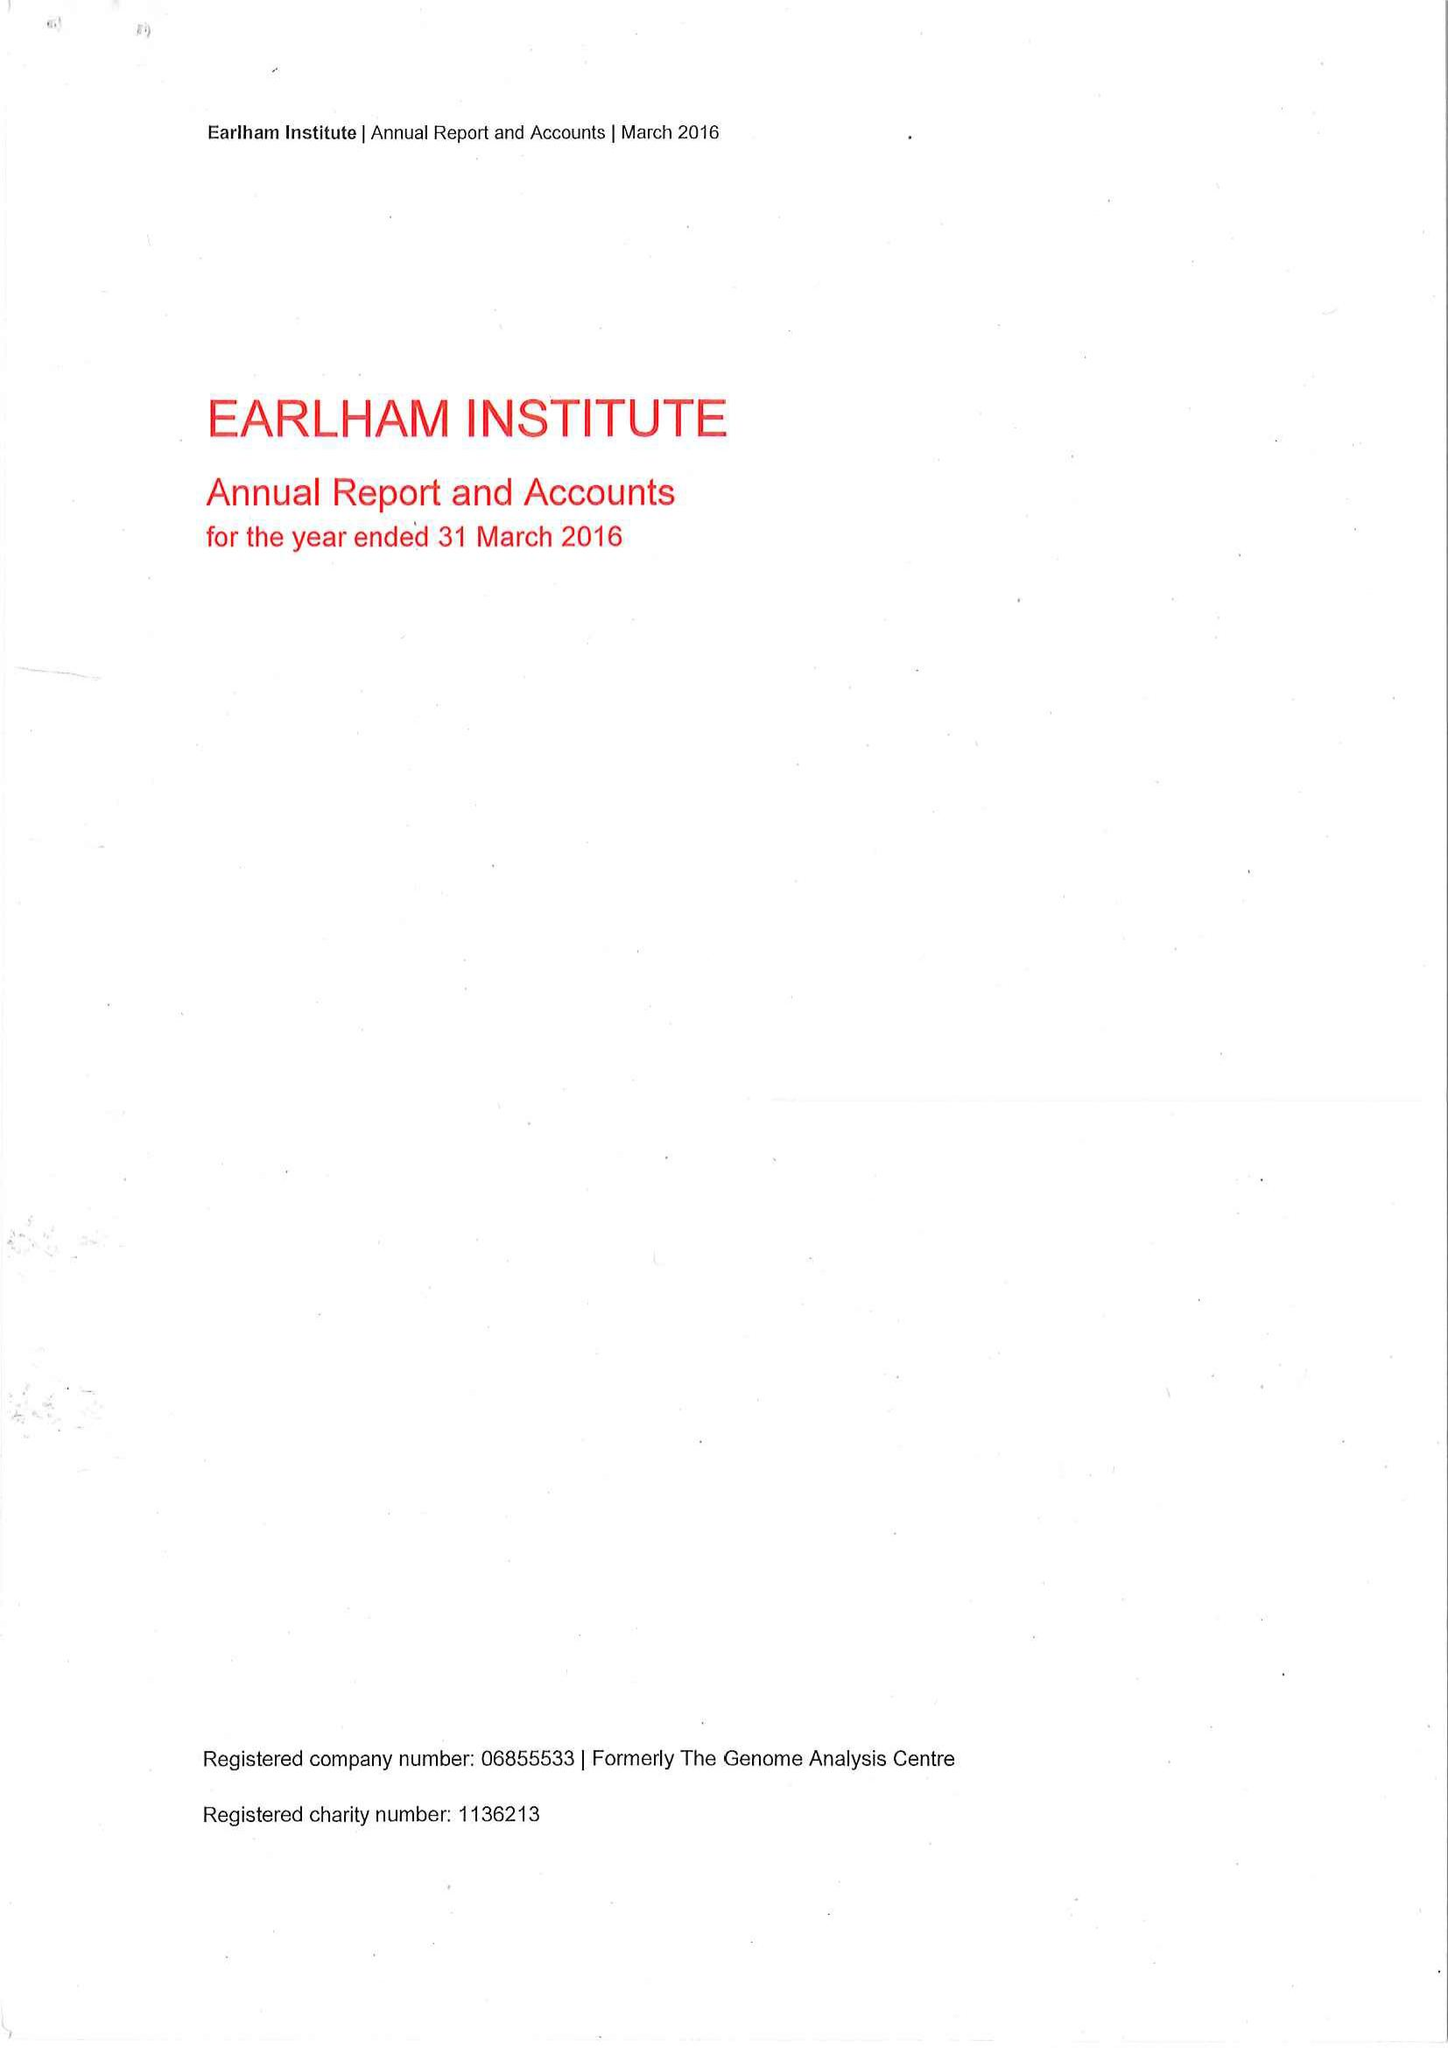What is the value for the spending_annually_in_british_pounds?
Answer the question using a single word or phrase. 15447000.00 